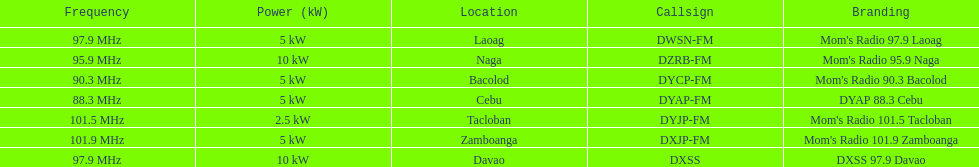How many stations broadcast with a power of 5kw? 4. 